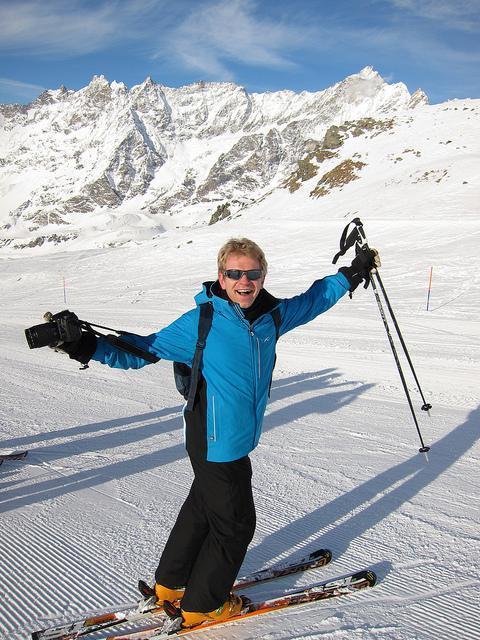How many blue trains can you see?
Give a very brief answer. 0. 